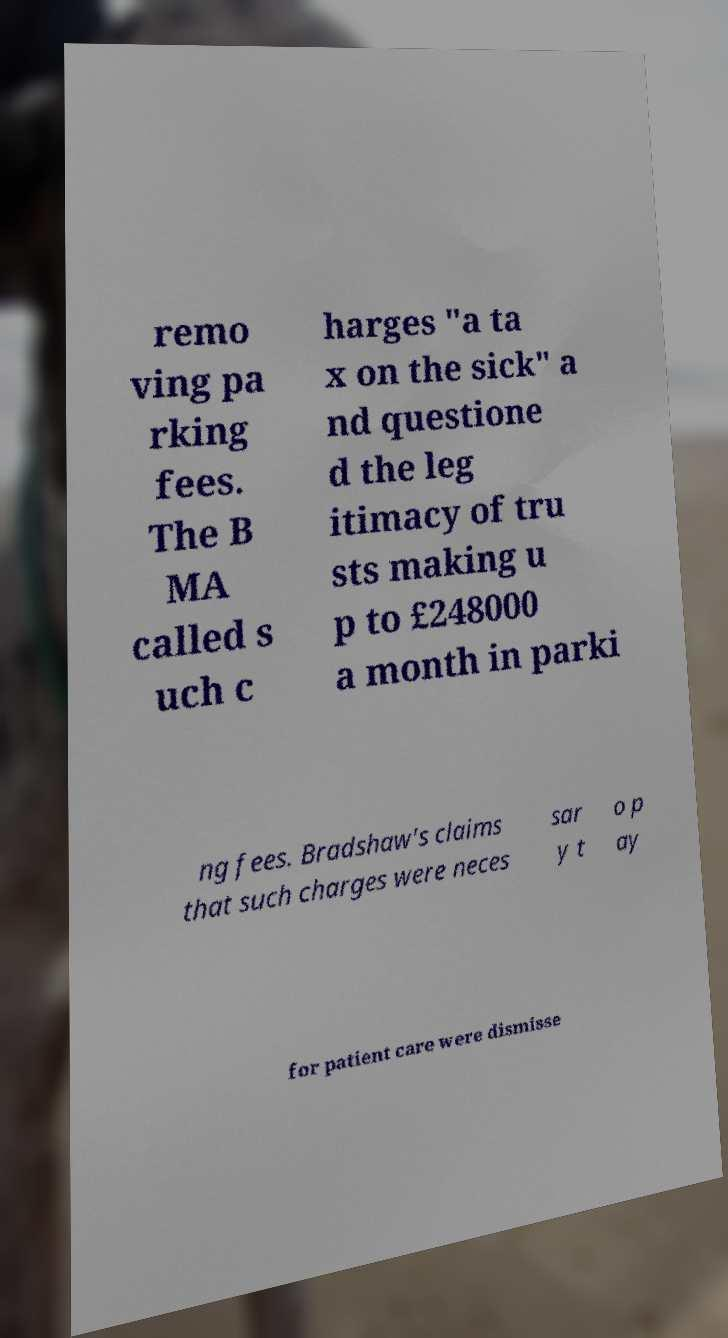For documentation purposes, I need the text within this image transcribed. Could you provide that? remo ving pa rking fees. The B MA called s uch c harges "a ta x on the sick" a nd questione d the leg itimacy of tru sts making u p to £248000 a month in parki ng fees. Bradshaw's claims that such charges were neces sar y t o p ay for patient care were dismisse 